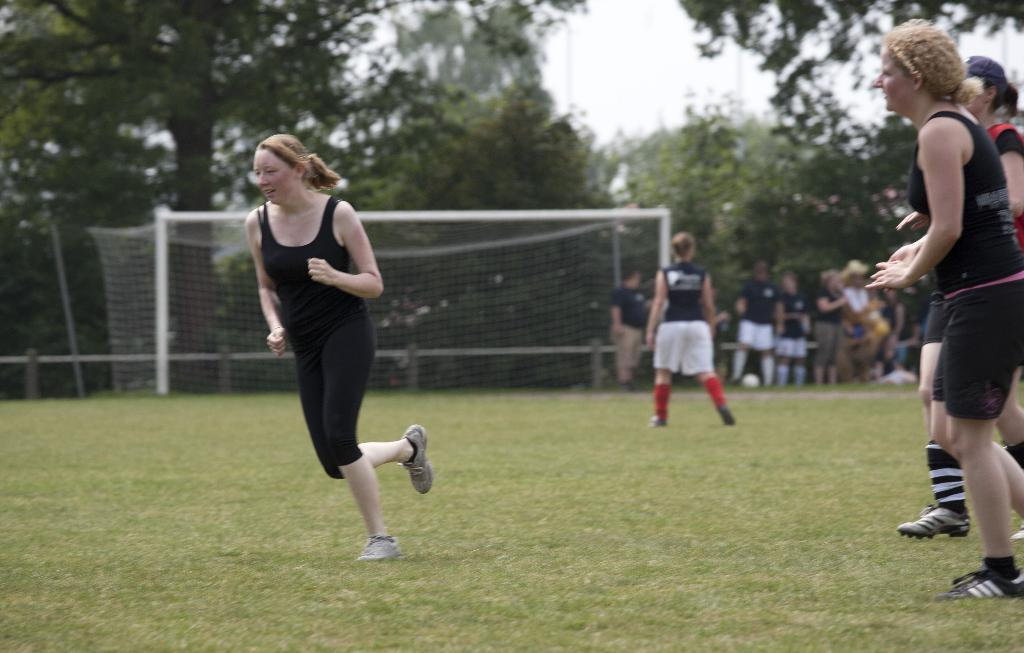What is the woman in the image doing? The woman is running in the image. What are the two people in the foreground of the image doing? They are walking on the grass in the image. Can you describe the background of the image? There are people, a net, trees, and the sky visible in the background of the image. Where is the tub located in the image? There is no tub present in the image. How many rabbits can be seen hopping in the background of the image? There are no rabbits present in the image. 